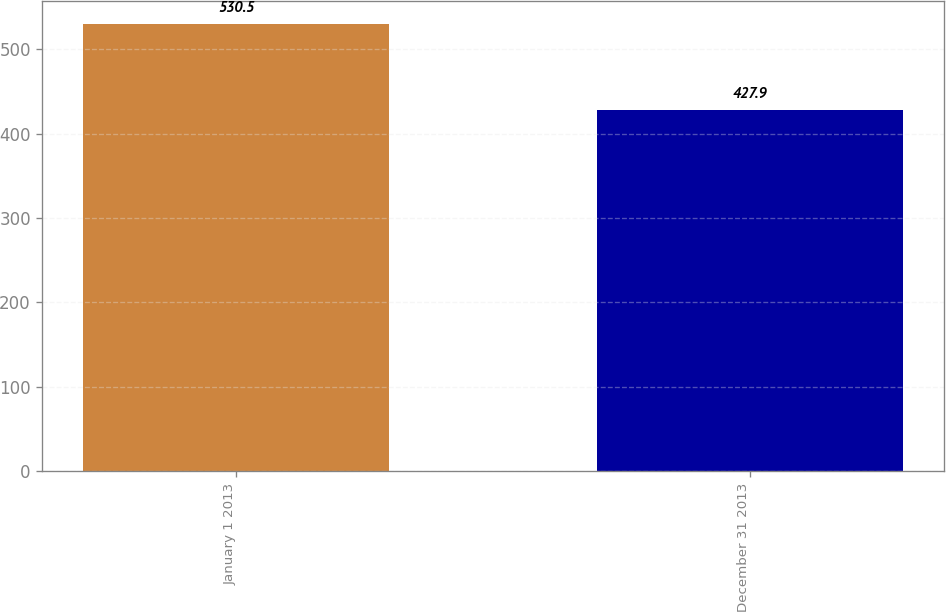Convert chart to OTSL. <chart><loc_0><loc_0><loc_500><loc_500><bar_chart><fcel>January 1 2013<fcel>December 31 2013<nl><fcel>530.5<fcel>427.9<nl></chart> 